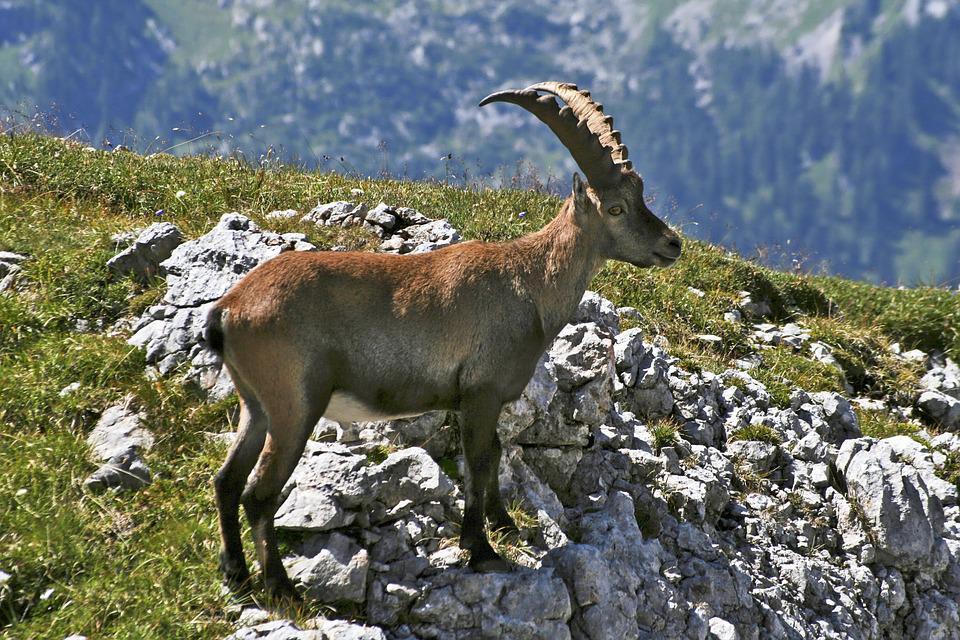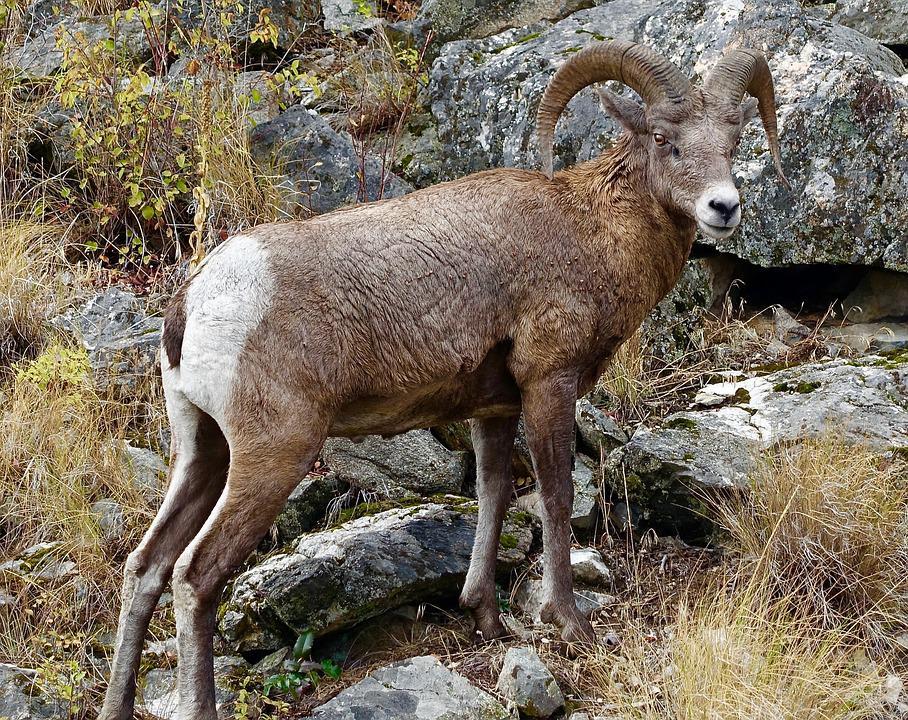The first image is the image on the left, the second image is the image on the right. For the images shown, is this caption "One image shows multiple antelope on a sheer rock wall bare of any foliage." true? Answer yes or no. No. 